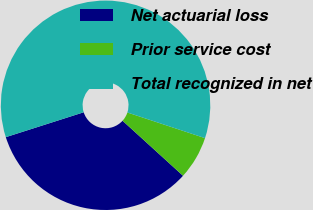Convert chart to OTSL. <chart><loc_0><loc_0><loc_500><loc_500><pie_chart><fcel>Net actuarial loss<fcel>Prior service cost<fcel>Total recognized in net<nl><fcel>33.33%<fcel>6.67%<fcel>60.0%<nl></chart> 